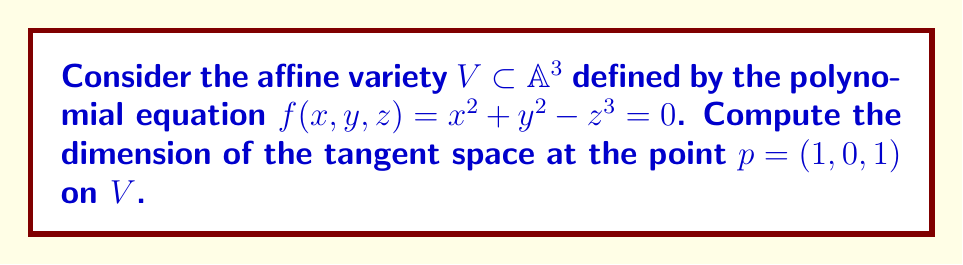Could you help me with this problem? To compute the dimension of the tangent space at a point on an affine variety, we follow these steps:

1) The tangent space at a point $p$ on an affine variety $V$ defined by polynomial equations $f_1, \ldots, f_r$ is given by the kernel of the Jacobian matrix evaluated at $p$.

2) In this case, we have one equation $f(x,y,z) = x^2 + y^2 - z^3 = 0$.

3) Compute the partial derivatives:
   $$\frac{\partial f}{\partial x} = 2x$$
   $$\frac{\partial f}{\partial y} = 2y$$
   $$\frac{\partial f}{\partial z} = -3z^2$$

4) The Jacobian matrix is:
   $$J = \begin{bmatrix} 
   \frac{\partial f}{\partial x} & \frac{\partial f}{\partial y} & \frac{\partial f}{\partial z}
   \end{bmatrix} = \begin{bmatrix} 
   2x & 2y & -3z^2
   \end{bmatrix}$$

5) Evaluate the Jacobian at the point $p = (1,0,1)$:
   $$J(p) = \begin{bmatrix} 
   2(1) & 2(0) & -3(1)^2
   \end{bmatrix} = \begin{bmatrix} 
   2 & 0 & -3
   \end{bmatrix}$$

6) The tangent space is the kernel of this matrix. It consists of vectors $(a,b,c)$ such that:
   $$\begin{bmatrix} 
   2 & 0 & -3
   \end{bmatrix} \begin{bmatrix} 
   a \\ b \\ c
   \end{bmatrix} = 0$$

7) This gives the equation: $2a - 3c = 0$ or $c = \frac{2}{3}a$

8) The general solution is:
   $$\begin{bmatrix} 
   a \\ b \\ \frac{2}{3}a
   \end{bmatrix} = a\begin{bmatrix} 
   1 \\ 0 \\ \frac{2}{3}
   \end{bmatrix} + b\begin{bmatrix} 
   0 \\ 1 \\ 0
   \end{bmatrix}$$

9) This shows that the tangent space is spanned by two linearly independent vectors.

Therefore, the dimension of the tangent space is 2.
Answer: 2 